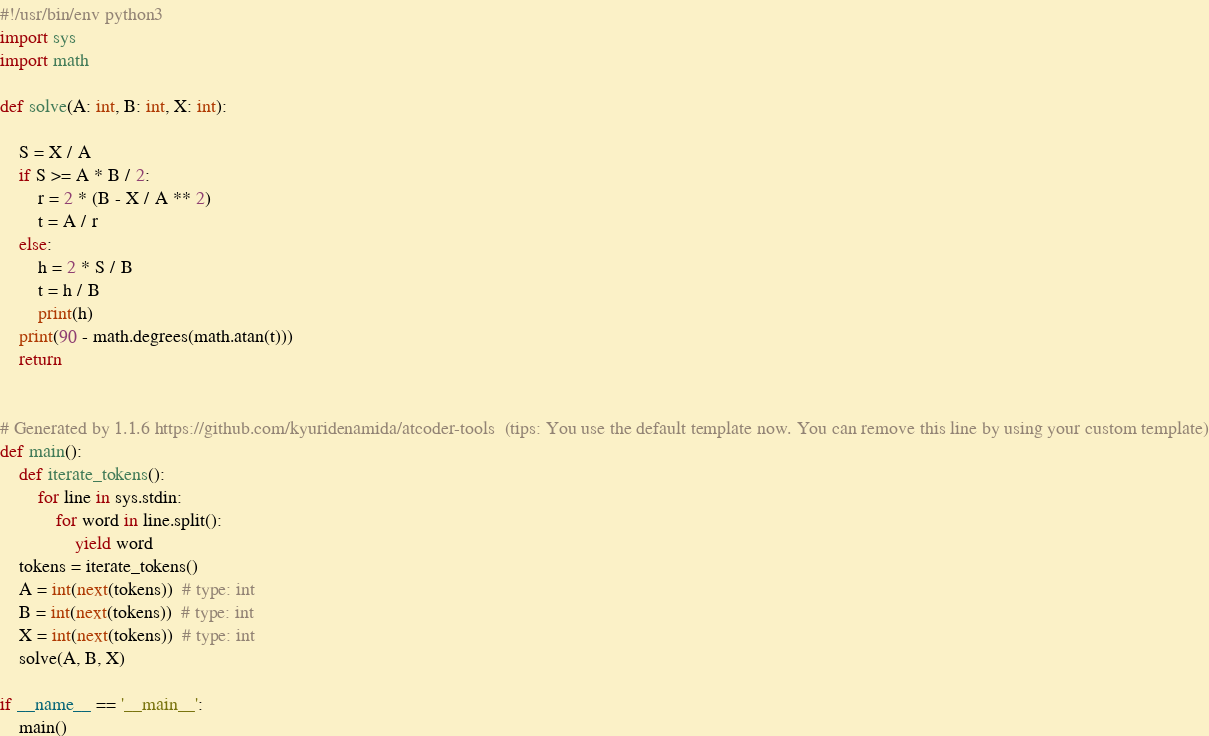<code> <loc_0><loc_0><loc_500><loc_500><_Python_>#!/usr/bin/env python3
import sys
import math

def solve(A: int, B: int, X: int):
    
    S = X / A
    if S >= A * B / 2:
        r = 2 * (B - X / A ** 2)
        t = A / r
    else:
        h = 2 * S / B
        t = h / B
        print(h)
    print(90 - math.degrees(math.atan(t)))
    return


# Generated by 1.1.6 https://github.com/kyuridenamida/atcoder-tools  (tips: You use the default template now. You can remove this line by using your custom template)
def main():
    def iterate_tokens():
        for line in sys.stdin:
            for word in line.split():
                yield word
    tokens = iterate_tokens()
    A = int(next(tokens))  # type: int
    B = int(next(tokens))  # type: int
    X = int(next(tokens))  # type: int
    solve(A, B, X)

if __name__ == '__main__':
    main()
</code> 